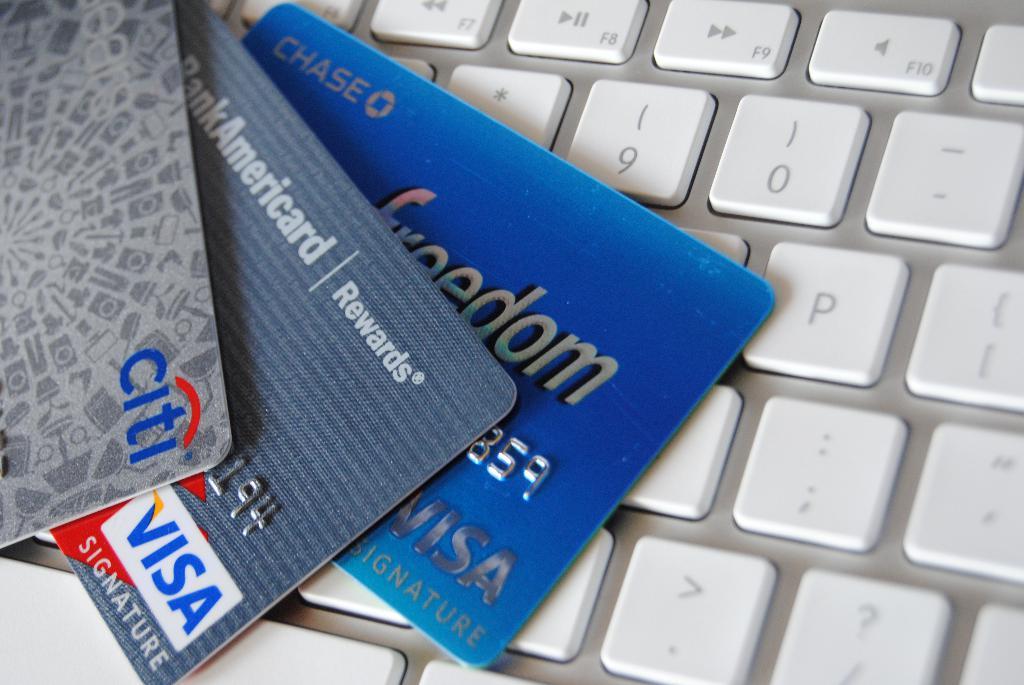What credit card is seen in the middle?
Your response must be concise. Visa. What bank is the top card from?
Give a very brief answer. Citi. 